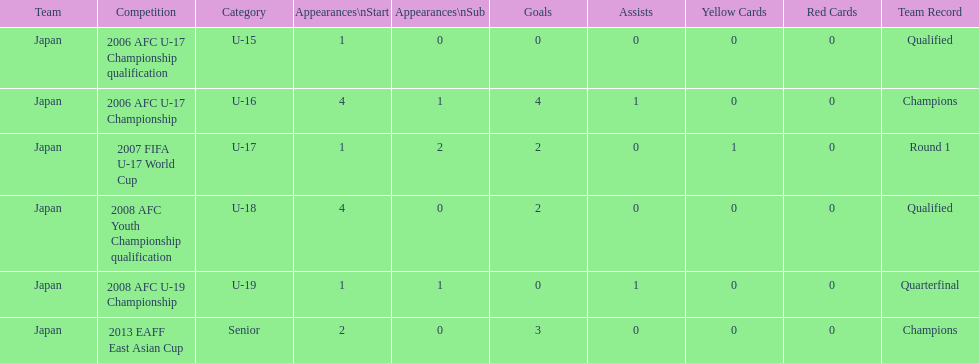Did japan have more starting appearances in the 2013 eaff east asian cup or 2007 fifa u-17 world cup? 2013 EAFF East Asian Cup. 